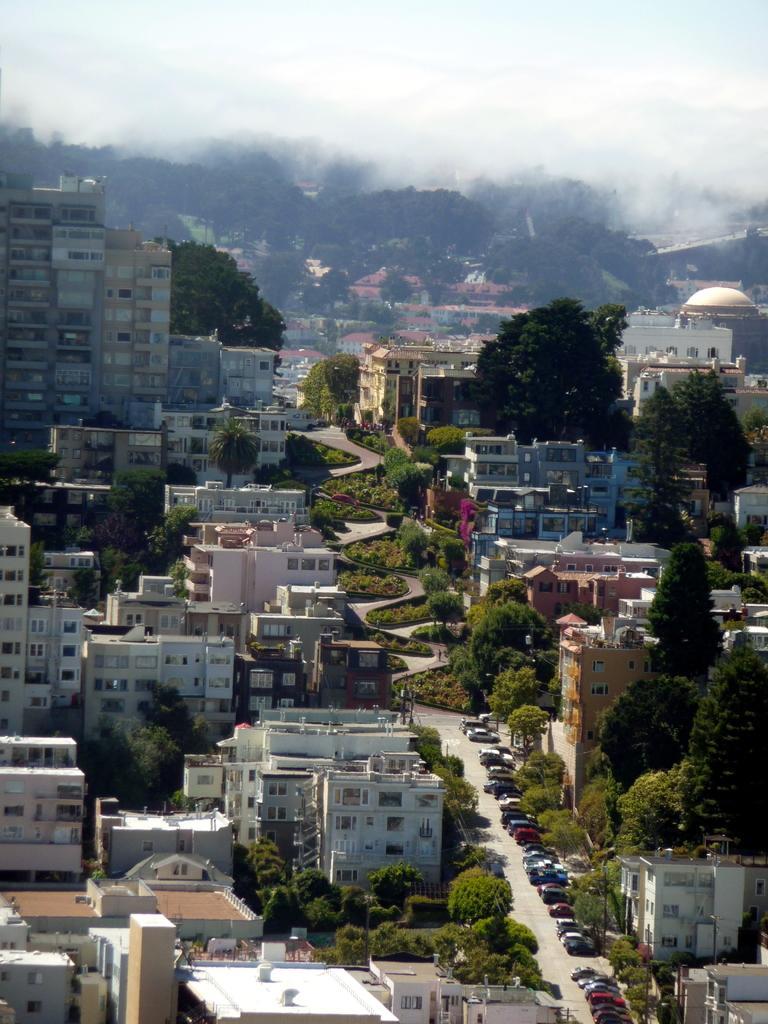How would you summarize this image in a sentence or two? In this picture we can see buildings and trees, on the right side there are cars, grass and plants, in the background we can see fog, there is the sky at the top of the picture. 